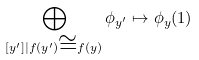<formula> <loc_0><loc_0><loc_500><loc_500>\bigoplus _ { [ y ^ { \prime } ] | f ( y ^ { \prime } ) \cong f ( y ) } \phi _ { y ^ { \prime } } \mapsto \phi _ { y } ( 1 )</formula> 